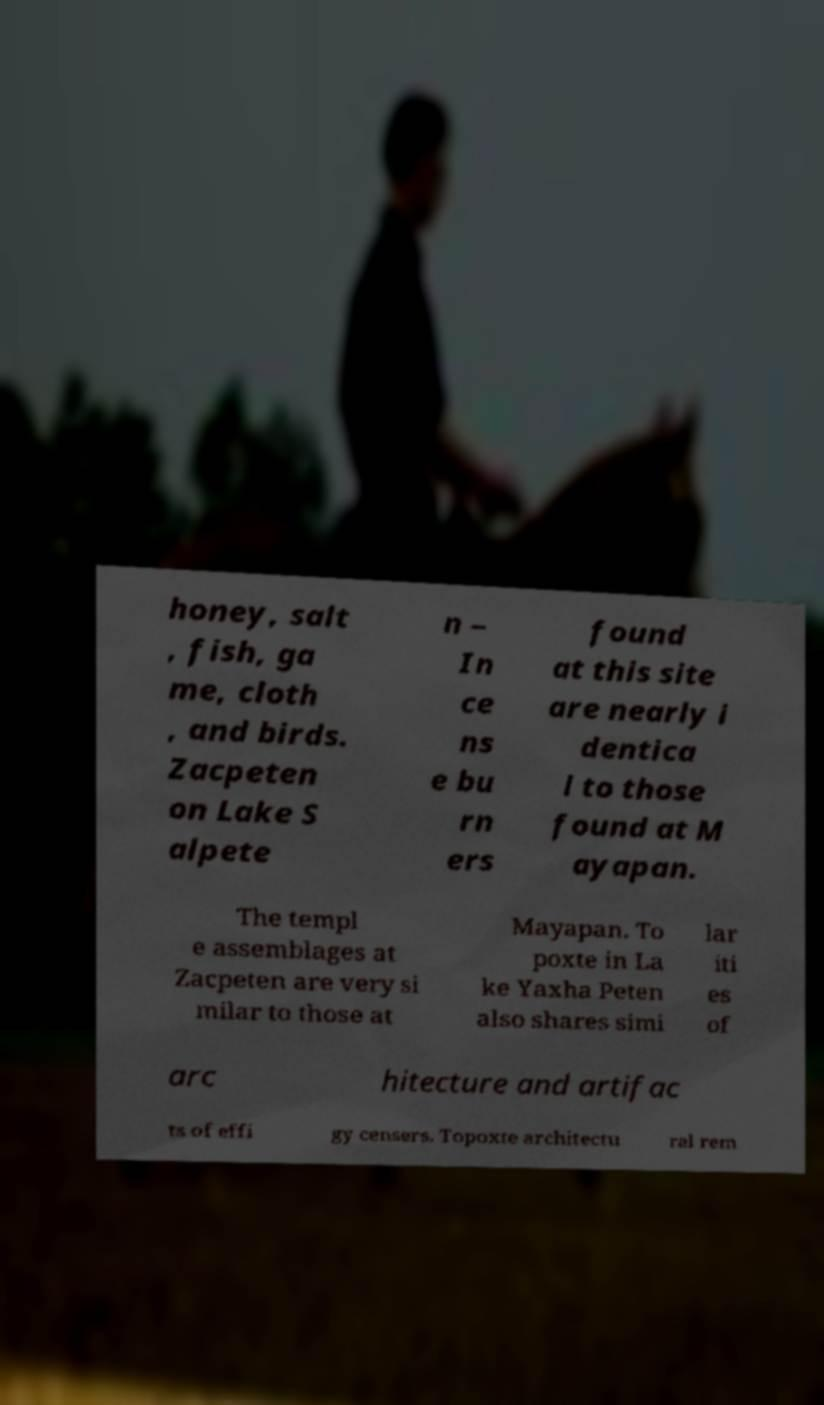There's text embedded in this image that I need extracted. Can you transcribe it verbatim? honey, salt , fish, ga me, cloth , and birds. Zacpeten on Lake S alpete n – In ce ns e bu rn ers found at this site are nearly i dentica l to those found at M ayapan. The templ e assemblages at Zacpeten are very si milar to those at Mayapan. To poxte in La ke Yaxha Peten also shares simi lar iti es of arc hitecture and artifac ts of effi gy censers. Topoxte architectu ral rem 